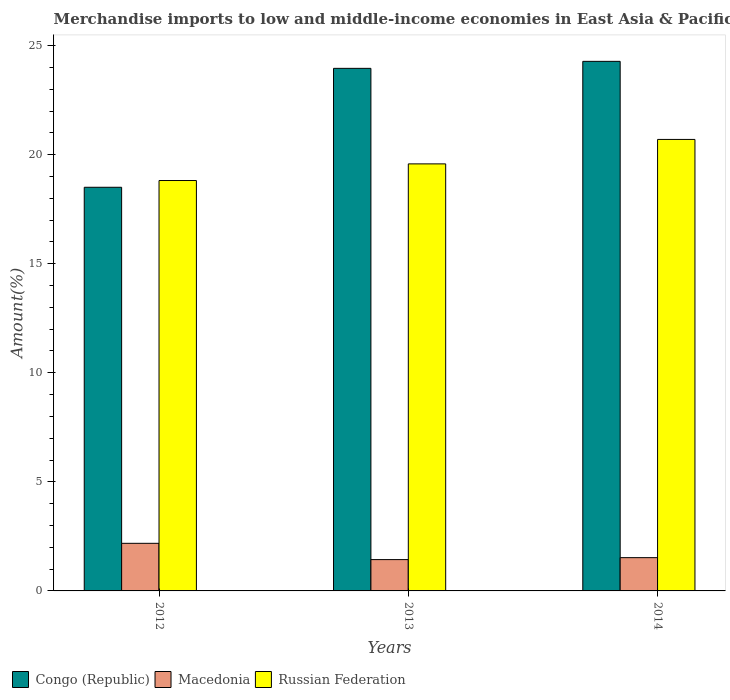Are the number of bars per tick equal to the number of legend labels?
Provide a short and direct response. Yes. Are the number of bars on each tick of the X-axis equal?
Give a very brief answer. Yes. How many bars are there on the 1st tick from the right?
Offer a very short reply. 3. What is the percentage of amount earned from merchandise imports in Congo (Republic) in 2012?
Your response must be concise. 18.51. Across all years, what is the maximum percentage of amount earned from merchandise imports in Macedonia?
Make the answer very short. 2.18. Across all years, what is the minimum percentage of amount earned from merchandise imports in Congo (Republic)?
Offer a very short reply. 18.51. In which year was the percentage of amount earned from merchandise imports in Congo (Republic) minimum?
Your answer should be compact. 2012. What is the total percentage of amount earned from merchandise imports in Congo (Republic) in the graph?
Offer a very short reply. 66.74. What is the difference between the percentage of amount earned from merchandise imports in Macedonia in 2012 and that in 2014?
Offer a terse response. 0.66. What is the difference between the percentage of amount earned from merchandise imports in Congo (Republic) in 2012 and the percentage of amount earned from merchandise imports in Macedonia in 2013?
Ensure brevity in your answer.  17.07. What is the average percentage of amount earned from merchandise imports in Macedonia per year?
Ensure brevity in your answer.  1.71. In the year 2013, what is the difference between the percentage of amount earned from merchandise imports in Russian Federation and percentage of amount earned from merchandise imports in Macedonia?
Make the answer very short. 18.14. What is the ratio of the percentage of amount earned from merchandise imports in Russian Federation in 2012 to that in 2014?
Keep it short and to the point. 0.91. What is the difference between the highest and the second highest percentage of amount earned from merchandise imports in Congo (Republic)?
Provide a short and direct response. 0.32. What is the difference between the highest and the lowest percentage of amount earned from merchandise imports in Russian Federation?
Offer a very short reply. 1.88. In how many years, is the percentage of amount earned from merchandise imports in Congo (Republic) greater than the average percentage of amount earned from merchandise imports in Congo (Republic) taken over all years?
Offer a very short reply. 2. Is the sum of the percentage of amount earned from merchandise imports in Russian Federation in 2012 and 2014 greater than the maximum percentage of amount earned from merchandise imports in Congo (Republic) across all years?
Keep it short and to the point. Yes. What does the 1st bar from the left in 2014 represents?
Make the answer very short. Congo (Republic). What does the 3rd bar from the right in 2013 represents?
Your answer should be compact. Congo (Republic). Is it the case that in every year, the sum of the percentage of amount earned from merchandise imports in Macedonia and percentage of amount earned from merchandise imports in Russian Federation is greater than the percentage of amount earned from merchandise imports in Congo (Republic)?
Keep it short and to the point. No. How many bars are there?
Your answer should be compact. 9. Are all the bars in the graph horizontal?
Make the answer very short. No. Are the values on the major ticks of Y-axis written in scientific E-notation?
Give a very brief answer. No. Does the graph contain any zero values?
Make the answer very short. No. How are the legend labels stacked?
Your answer should be compact. Horizontal. What is the title of the graph?
Ensure brevity in your answer.  Merchandise imports to low and middle-income economies in East Asia & Pacific. Does "Qatar" appear as one of the legend labels in the graph?
Give a very brief answer. No. What is the label or title of the Y-axis?
Your answer should be very brief. Amount(%). What is the Amount(%) of Congo (Republic) in 2012?
Provide a succinct answer. 18.51. What is the Amount(%) in Macedonia in 2012?
Offer a terse response. 2.18. What is the Amount(%) in Russian Federation in 2012?
Offer a terse response. 18.82. What is the Amount(%) in Congo (Republic) in 2013?
Your response must be concise. 23.96. What is the Amount(%) in Macedonia in 2013?
Your response must be concise. 1.44. What is the Amount(%) in Russian Federation in 2013?
Offer a very short reply. 19.58. What is the Amount(%) of Congo (Republic) in 2014?
Offer a terse response. 24.28. What is the Amount(%) in Macedonia in 2014?
Offer a terse response. 1.53. What is the Amount(%) of Russian Federation in 2014?
Provide a succinct answer. 20.7. Across all years, what is the maximum Amount(%) of Congo (Republic)?
Provide a succinct answer. 24.28. Across all years, what is the maximum Amount(%) of Macedonia?
Provide a succinct answer. 2.18. Across all years, what is the maximum Amount(%) in Russian Federation?
Your answer should be very brief. 20.7. Across all years, what is the minimum Amount(%) of Congo (Republic)?
Keep it short and to the point. 18.51. Across all years, what is the minimum Amount(%) of Macedonia?
Offer a terse response. 1.44. Across all years, what is the minimum Amount(%) in Russian Federation?
Provide a succinct answer. 18.82. What is the total Amount(%) of Congo (Republic) in the graph?
Keep it short and to the point. 66.74. What is the total Amount(%) in Macedonia in the graph?
Make the answer very short. 5.14. What is the total Amount(%) of Russian Federation in the graph?
Provide a succinct answer. 59.09. What is the difference between the Amount(%) of Congo (Republic) in 2012 and that in 2013?
Provide a short and direct response. -5.45. What is the difference between the Amount(%) in Macedonia in 2012 and that in 2013?
Give a very brief answer. 0.75. What is the difference between the Amount(%) of Russian Federation in 2012 and that in 2013?
Keep it short and to the point. -0.76. What is the difference between the Amount(%) in Congo (Republic) in 2012 and that in 2014?
Your answer should be compact. -5.77. What is the difference between the Amount(%) of Macedonia in 2012 and that in 2014?
Provide a succinct answer. 0.66. What is the difference between the Amount(%) in Russian Federation in 2012 and that in 2014?
Your answer should be very brief. -1.88. What is the difference between the Amount(%) of Congo (Republic) in 2013 and that in 2014?
Keep it short and to the point. -0.32. What is the difference between the Amount(%) in Macedonia in 2013 and that in 2014?
Provide a short and direct response. -0.09. What is the difference between the Amount(%) in Russian Federation in 2013 and that in 2014?
Offer a terse response. -1.12. What is the difference between the Amount(%) in Congo (Republic) in 2012 and the Amount(%) in Macedonia in 2013?
Your answer should be very brief. 17.07. What is the difference between the Amount(%) in Congo (Republic) in 2012 and the Amount(%) in Russian Federation in 2013?
Your response must be concise. -1.07. What is the difference between the Amount(%) of Macedonia in 2012 and the Amount(%) of Russian Federation in 2013?
Provide a short and direct response. -17.4. What is the difference between the Amount(%) of Congo (Republic) in 2012 and the Amount(%) of Macedonia in 2014?
Your answer should be very brief. 16.98. What is the difference between the Amount(%) in Congo (Republic) in 2012 and the Amount(%) in Russian Federation in 2014?
Make the answer very short. -2.19. What is the difference between the Amount(%) in Macedonia in 2012 and the Amount(%) in Russian Federation in 2014?
Your answer should be compact. -18.52. What is the difference between the Amount(%) of Congo (Republic) in 2013 and the Amount(%) of Macedonia in 2014?
Your response must be concise. 22.43. What is the difference between the Amount(%) in Congo (Republic) in 2013 and the Amount(%) in Russian Federation in 2014?
Your response must be concise. 3.26. What is the difference between the Amount(%) in Macedonia in 2013 and the Amount(%) in Russian Federation in 2014?
Your answer should be very brief. -19.26. What is the average Amount(%) of Congo (Republic) per year?
Your answer should be very brief. 22.25. What is the average Amount(%) of Macedonia per year?
Offer a terse response. 1.71. What is the average Amount(%) in Russian Federation per year?
Keep it short and to the point. 19.7. In the year 2012, what is the difference between the Amount(%) of Congo (Republic) and Amount(%) of Macedonia?
Provide a succinct answer. 16.32. In the year 2012, what is the difference between the Amount(%) of Congo (Republic) and Amount(%) of Russian Federation?
Give a very brief answer. -0.31. In the year 2012, what is the difference between the Amount(%) in Macedonia and Amount(%) in Russian Federation?
Make the answer very short. -16.63. In the year 2013, what is the difference between the Amount(%) in Congo (Republic) and Amount(%) in Macedonia?
Your response must be concise. 22.52. In the year 2013, what is the difference between the Amount(%) in Congo (Republic) and Amount(%) in Russian Federation?
Your answer should be compact. 4.38. In the year 2013, what is the difference between the Amount(%) of Macedonia and Amount(%) of Russian Federation?
Offer a very short reply. -18.14. In the year 2014, what is the difference between the Amount(%) of Congo (Republic) and Amount(%) of Macedonia?
Offer a terse response. 22.75. In the year 2014, what is the difference between the Amount(%) of Congo (Republic) and Amount(%) of Russian Federation?
Provide a short and direct response. 3.58. In the year 2014, what is the difference between the Amount(%) of Macedonia and Amount(%) of Russian Federation?
Ensure brevity in your answer.  -19.17. What is the ratio of the Amount(%) of Congo (Republic) in 2012 to that in 2013?
Provide a succinct answer. 0.77. What is the ratio of the Amount(%) in Macedonia in 2012 to that in 2013?
Your answer should be very brief. 1.52. What is the ratio of the Amount(%) in Congo (Republic) in 2012 to that in 2014?
Provide a short and direct response. 0.76. What is the ratio of the Amount(%) of Macedonia in 2012 to that in 2014?
Keep it short and to the point. 1.43. What is the ratio of the Amount(%) in Russian Federation in 2012 to that in 2014?
Your answer should be compact. 0.91. What is the ratio of the Amount(%) of Macedonia in 2013 to that in 2014?
Make the answer very short. 0.94. What is the ratio of the Amount(%) of Russian Federation in 2013 to that in 2014?
Keep it short and to the point. 0.95. What is the difference between the highest and the second highest Amount(%) of Congo (Republic)?
Provide a short and direct response. 0.32. What is the difference between the highest and the second highest Amount(%) in Macedonia?
Give a very brief answer. 0.66. What is the difference between the highest and the second highest Amount(%) of Russian Federation?
Provide a short and direct response. 1.12. What is the difference between the highest and the lowest Amount(%) of Congo (Republic)?
Your answer should be very brief. 5.77. What is the difference between the highest and the lowest Amount(%) of Macedonia?
Make the answer very short. 0.75. What is the difference between the highest and the lowest Amount(%) of Russian Federation?
Offer a terse response. 1.88. 